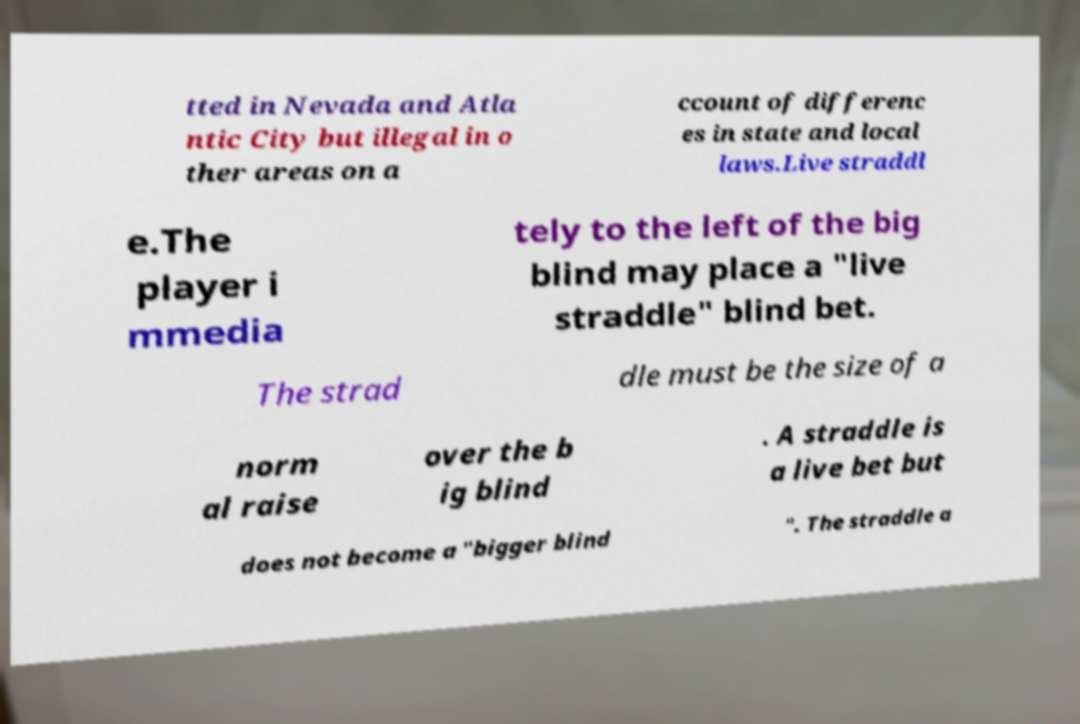Could you assist in decoding the text presented in this image and type it out clearly? tted in Nevada and Atla ntic City but illegal in o ther areas on a ccount of differenc es in state and local laws.Live straddl e.The player i mmedia tely to the left of the big blind may place a "live straddle" blind bet. The strad dle must be the size of a norm al raise over the b ig blind . A straddle is a live bet but does not become a "bigger blind ". The straddle a 